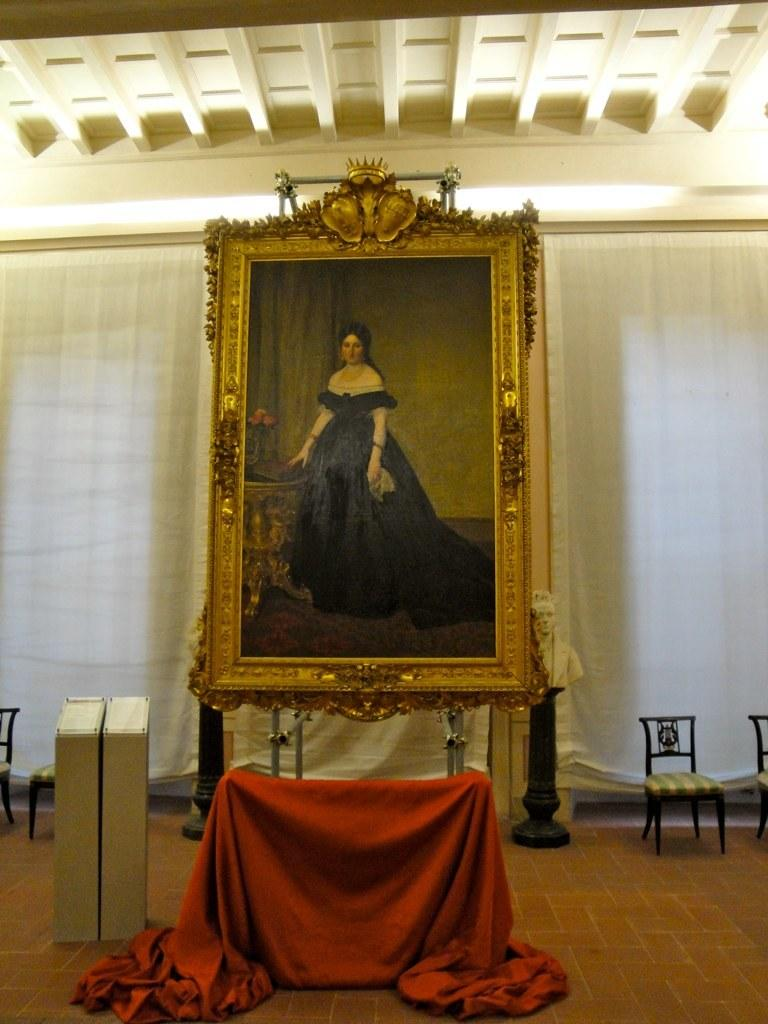What is the main subject of the image? The main subject of the image is a photo frame of a woman. Can you describe anything else in the image besides the photo frame? Yes, there is a curtain beside the photo frame in the image. What type of playground equipment can be seen in the image? There is no playground equipment present in the image. What effect does the cactus have on the photo frame in the image? There is no cactus present in the image, so it cannot have any effect on the photo frame. 